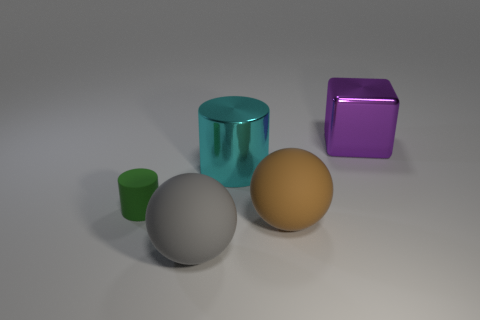Add 2 big green metal balls. How many objects exist? 7 Subtract all cubes. How many objects are left? 4 Add 1 brown things. How many brown things are left? 2 Add 1 cylinders. How many cylinders exist? 3 Subtract 0 gray blocks. How many objects are left? 5 Subtract all large gray matte things. Subtract all large gray metallic things. How many objects are left? 4 